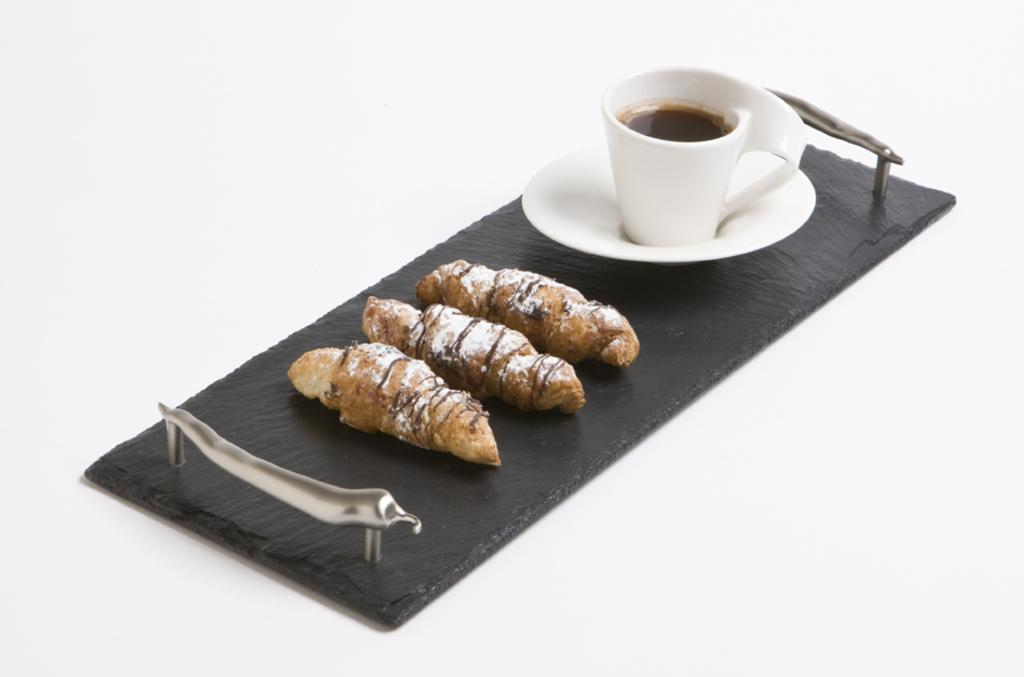What is on the tray that is visible in the image? There is a tray with food items in the image. What other items can be seen in the image besides the tray? There is a saucer and a cup with a drink in the image. What type of hat is the food wearing in the image? There is no hat present in the image, as the food items are not wearing any clothing or accessories. 